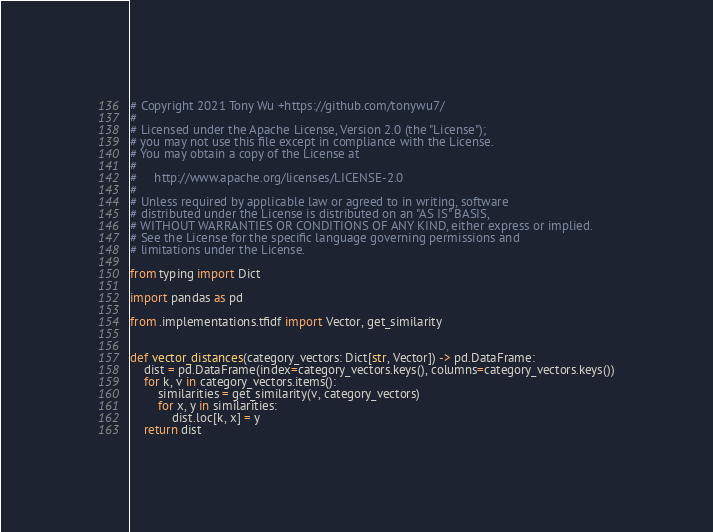Convert code to text. <code><loc_0><loc_0><loc_500><loc_500><_Python_># Copyright 2021 Tony Wu +https://github.com/tonywu7/
#
# Licensed under the Apache License, Version 2.0 (the "License");
# you may not use this file except in compliance with the License.
# You may obtain a copy of the License at
#
#     http://www.apache.org/licenses/LICENSE-2.0
#
# Unless required by applicable law or agreed to in writing, software
# distributed under the License is distributed on an "AS IS" BASIS,
# WITHOUT WARRANTIES OR CONDITIONS OF ANY KIND, either express or implied.
# See the License for the specific language governing permissions and
# limitations under the License.

from typing import Dict

import pandas as pd

from .implementations.tfidf import Vector, get_similarity


def vector_distances(category_vectors: Dict[str, Vector]) -> pd.DataFrame:
    dist = pd.DataFrame(index=category_vectors.keys(), columns=category_vectors.keys())
    for k, v in category_vectors.items():
        similarities = get_similarity(v, category_vectors)
        for x, y in similarities:
            dist.loc[k, x] = y
    return dist
</code> 